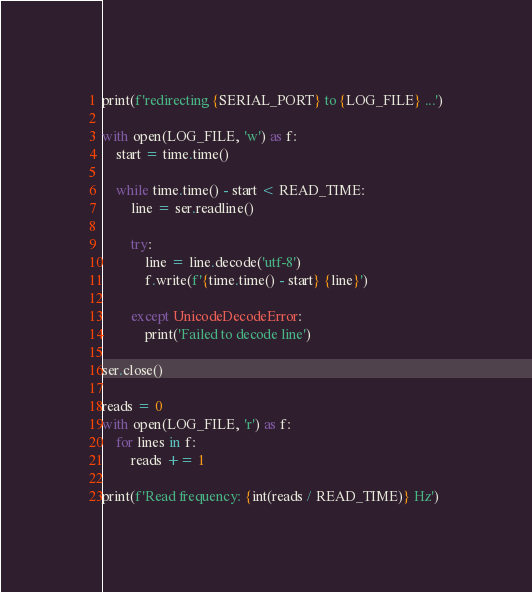Convert code to text. <code><loc_0><loc_0><loc_500><loc_500><_Python_>
print(f'redirecting {SERIAL_PORT} to {LOG_FILE} ...')

with open(LOG_FILE, 'w') as f:
    start = time.time()

    while time.time() - start < READ_TIME:
        line = ser.readline()

        try:
            line = line.decode('utf-8')
            f.write(f'{time.time() - start} {line}')

        except UnicodeDecodeError:
            print('Failed to decode line')

ser.close()

reads = 0
with open(LOG_FILE, 'r') as f:
    for lines in f:
        reads += 1

print(f'Read frequency: {int(reads / READ_TIME)} Hz')
</code> 